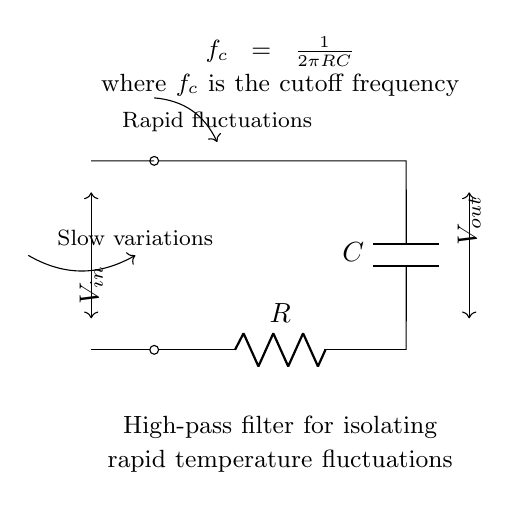What is the cutoff frequency formula for this circuit? The cutoff frequency formula is shown in the circuit diagram as \( f_c = \frac{1}{2\pi RC} \). This indicates how the frequency at which the output starts to reduce relative to the input is determined by the resistor and capacitor values.
Answer: f_c = 1/(2πRC) What type of filter is represented in this circuit? The circuit diagram is labeled as a high-pass filter, which means it is designed to allow high-frequency signals to pass through while attenuating low-frequency signals.
Answer: High-pass filter What are the components used in this high-pass filter? The components labeled in the circuit diagram are a resistor \( R \) and a capacitor \( C \). These two components are essential for the functioning of the high-pass filter.
Answer: Resistor and capacitor In which direction do rapid fluctuations pass through the circuit? The circuit diagram shows an arrow indicating that rapid fluctuations enter the circuit at the input and exit at the output, confirming their passage through the filter.
Answer: Forward What effect do slow variations have in this circuit? The circuit diagram indicates that slow variations are attenuated, as illustrated by the arrow that bends away from the output, showing they are not effectively passed through the filter.
Answer: Attenuated What happens to the output voltage for frequencies above the cutoff frequency? In a high-pass filter, at frequencies above the cutoff frequency, the output voltage approaches the input voltage, assuming ideal conditions. This indicates minimal attenuation for these higher frequencies.
Answer: Approaches input voltage How does the resistance value affect the cutoff frequency? The formula for the cutoff frequency indicates that as the resistance \( R \) increases, the cutoff frequency \( f_c \) decreases. This means higher resistance results in a lower frequency cutoff, impacting what fluctuations are passed or attenuated.
Answer: Inversely related 